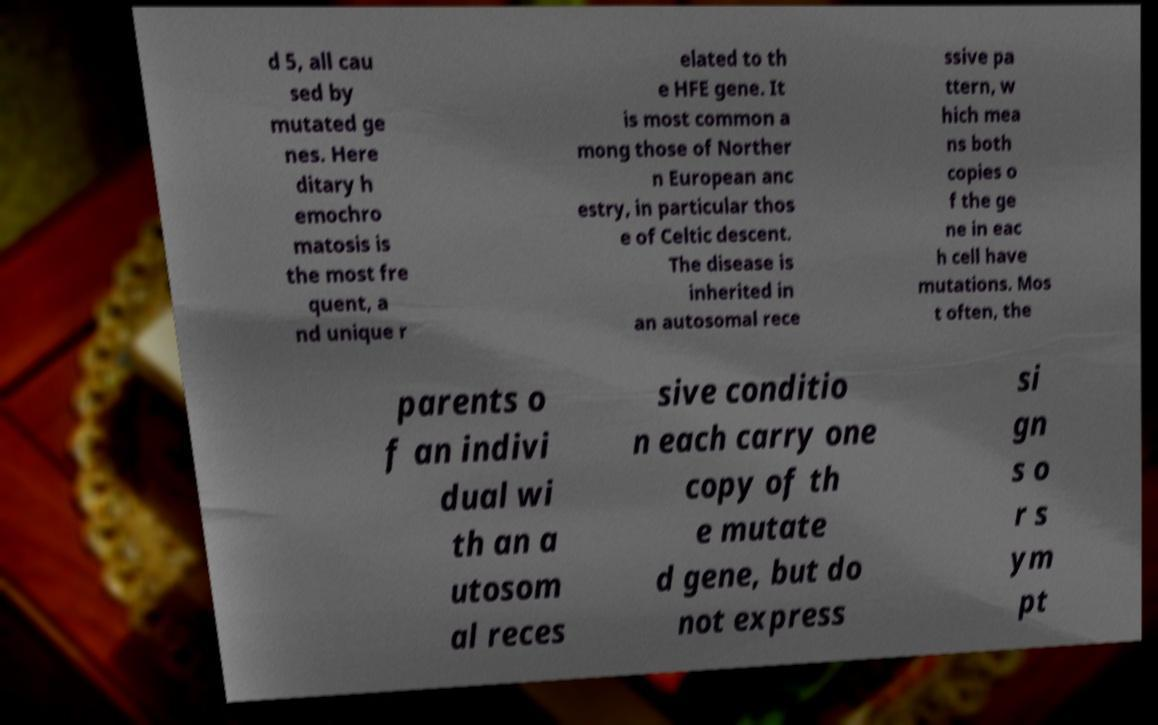What messages or text are displayed in this image? I need them in a readable, typed format. d 5, all cau sed by mutated ge nes. Here ditary h emochro matosis is the most fre quent, a nd unique r elated to th e HFE gene. It is most common a mong those of Norther n European anc estry, in particular thos e of Celtic descent. The disease is inherited in an autosomal rece ssive pa ttern, w hich mea ns both copies o f the ge ne in eac h cell have mutations. Mos t often, the parents o f an indivi dual wi th an a utosom al reces sive conditio n each carry one copy of th e mutate d gene, but do not express si gn s o r s ym pt 